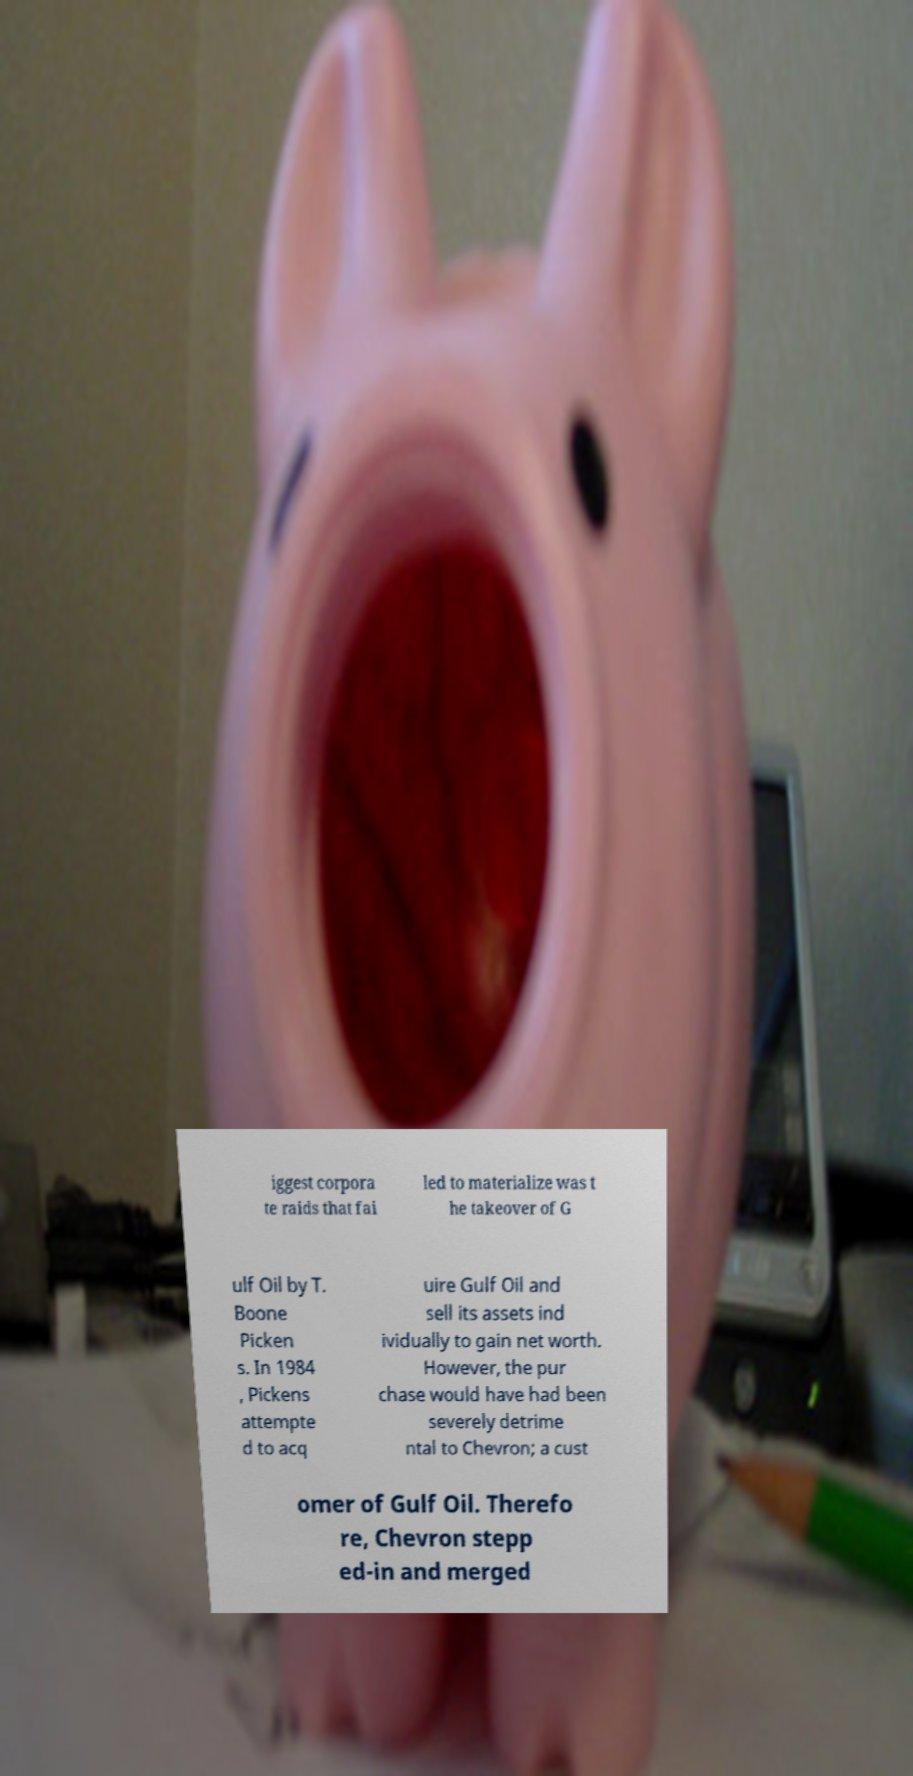What messages or text are displayed in this image? I need them in a readable, typed format. iggest corpora te raids that fai led to materialize was t he takeover of G ulf Oil by T. Boone Picken s. In 1984 , Pickens attempte d to acq uire Gulf Oil and sell its assets ind ividually to gain net worth. However, the pur chase would have had been severely detrime ntal to Chevron; a cust omer of Gulf Oil. Therefo re, Chevron stepp ed-in and merged 